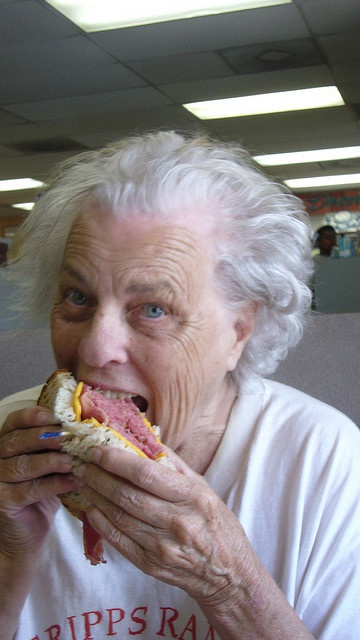Describe the objects in this image and their specific colors. I can see people in gray, darkgray, and lavender tones, sandwich in gray, maroon, darkgray, lightpink, and brown tones, and people in gray, black, and teal tones in this image. 